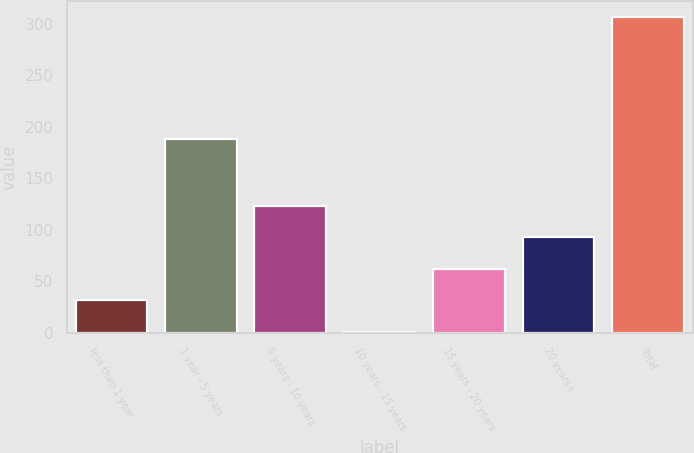Convert chart. <chart><loc_0><loc_0><loc_500><loc_500><bar_chart><fcel>less than 1 year<fcel>1 year - 5 years<fcel>5 years - 10 years<fcel>10 years - 15 years<fcel>15 years - 20 years<fcel>20 years+<fcel>Total<nl><fcel>31.83<fcel>188.2<fcel>123.42<fcel>1.3<fcel>62.36<fcel>92.89<fcel>306.6<nl></chart> 